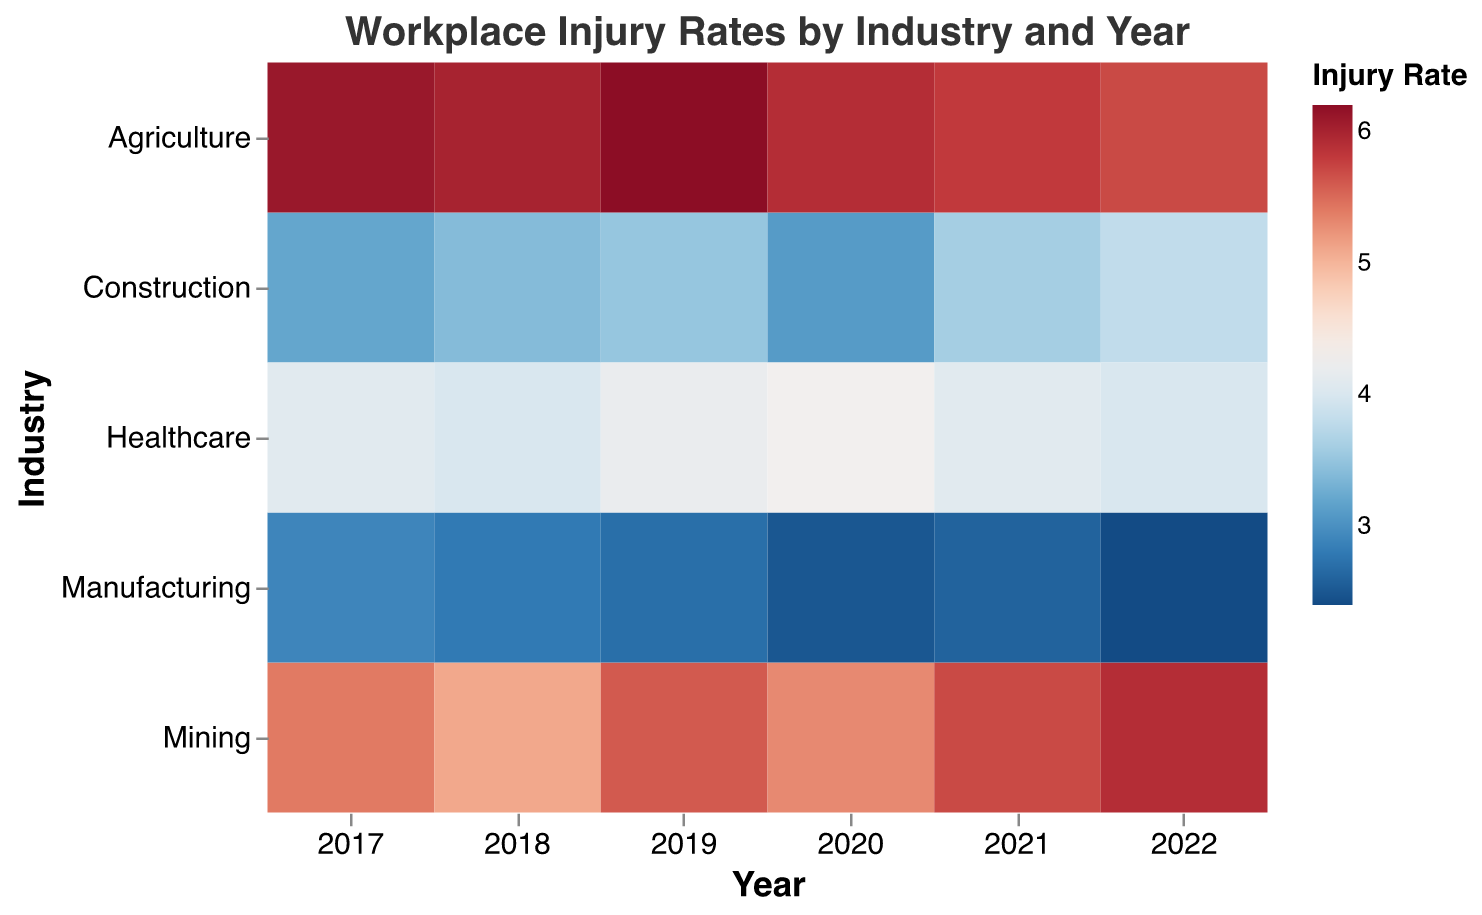What is the title of the figure? The title is located at the top of the figure and is usually the first thing people read when they look at the figure.
Answer: Workplace Injury Rates by Industry and Year Which industry had the highest injury rate in 2022? By looking at the color intensity for the year 2022, the darkest color indicating the highest rate is in the Agriculture row.
Answer: Agriculture Has the injury rate in mining increased or decreased from 2017 to 2022? By visually comparing the colors in the Mining row from 2017 to 2022, we observe that the color gets darker, indicating an increase in the injury rate.
Answer: Increased Which year had the lowest injury rate for the construction industry? Observing the color intensity for the construction industry across all years, the lightest color (indicating the lowest injury rate) is noticed in 2020.
Answer: 2020 Which industry has shown a consistent decrease in injury rates from 2017 to 2022? By visually inspecting the trend in colors for all industries, Manufacturing shows a consistent lightening from 2017 to 2022 indicating a decrease in injury rates.
Answer: Manufacturing In which year did healthcare exhibit the highest injury rate? By examining the color intensity in the Healthcare row, 2020 has the darkest color indicating the highest injury rate.
Answer: 2020 What is the difference in injury rates between Mining and Construction in 2022? The color for Mining in 2022 is darker (rate of 5.9) compared to Construction (rate of 3.8). Subtracting the Construction rate from the Mining rate: 5.9 - 3.8 = 2.1
Answer: 2.1 Which industry consistently had the highest injury rates from 2017 to 2022? By examining all rows, Agriculture constantly shows the darkest colors over the 6-year period.
Answer: Agriculture 